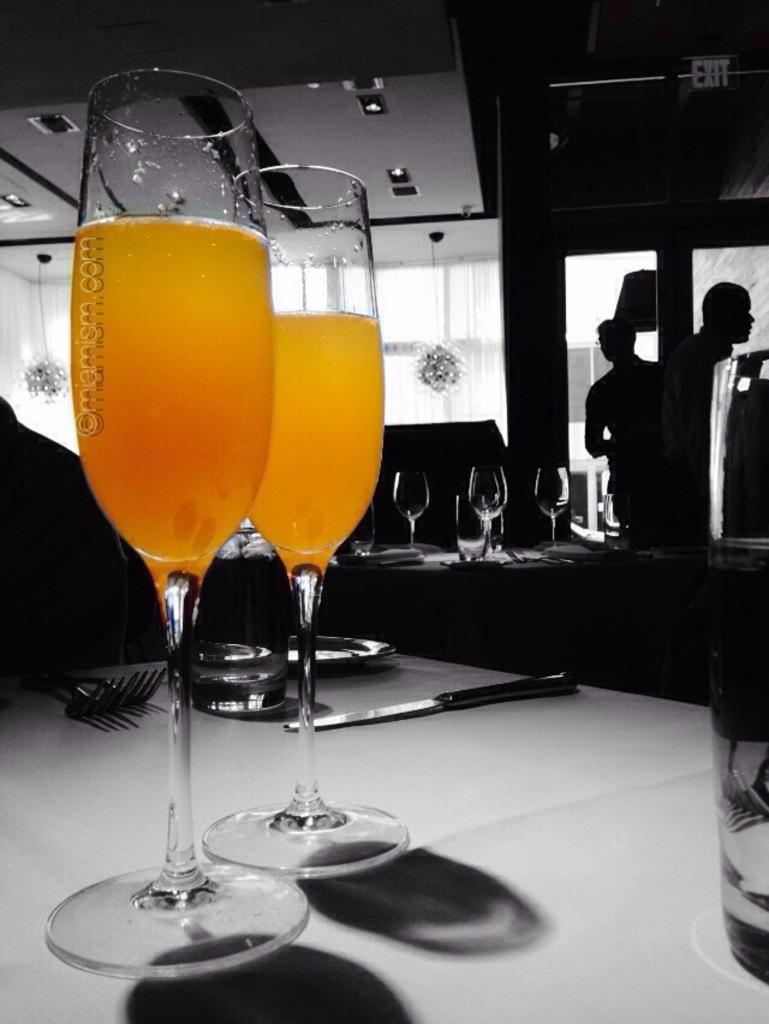What is in the glasses that are visible in the image? There are two glasses with juice in the image. What other items can be seen in the image? There is a knife, a plate, and forks visible in the image. How many additional glasses are present in the image? There are additional glasses in the image. Where are the glasses, knife, plate, and forks located? The glasses, knife, plate, and forks are on a table. How many people are in the image? There are two persons standing in the image. What is visible at the top of the image? There are lights visible at the top of the image. Can you tell me how many dinosaurs are sitting at the table in the image? There are no dinosaurs present in the image; it features glasses, a knife, a plate, forks, and two persons standing. What type of crown is the secretary wearing in the image? There is no crown or secretary present in the image. 